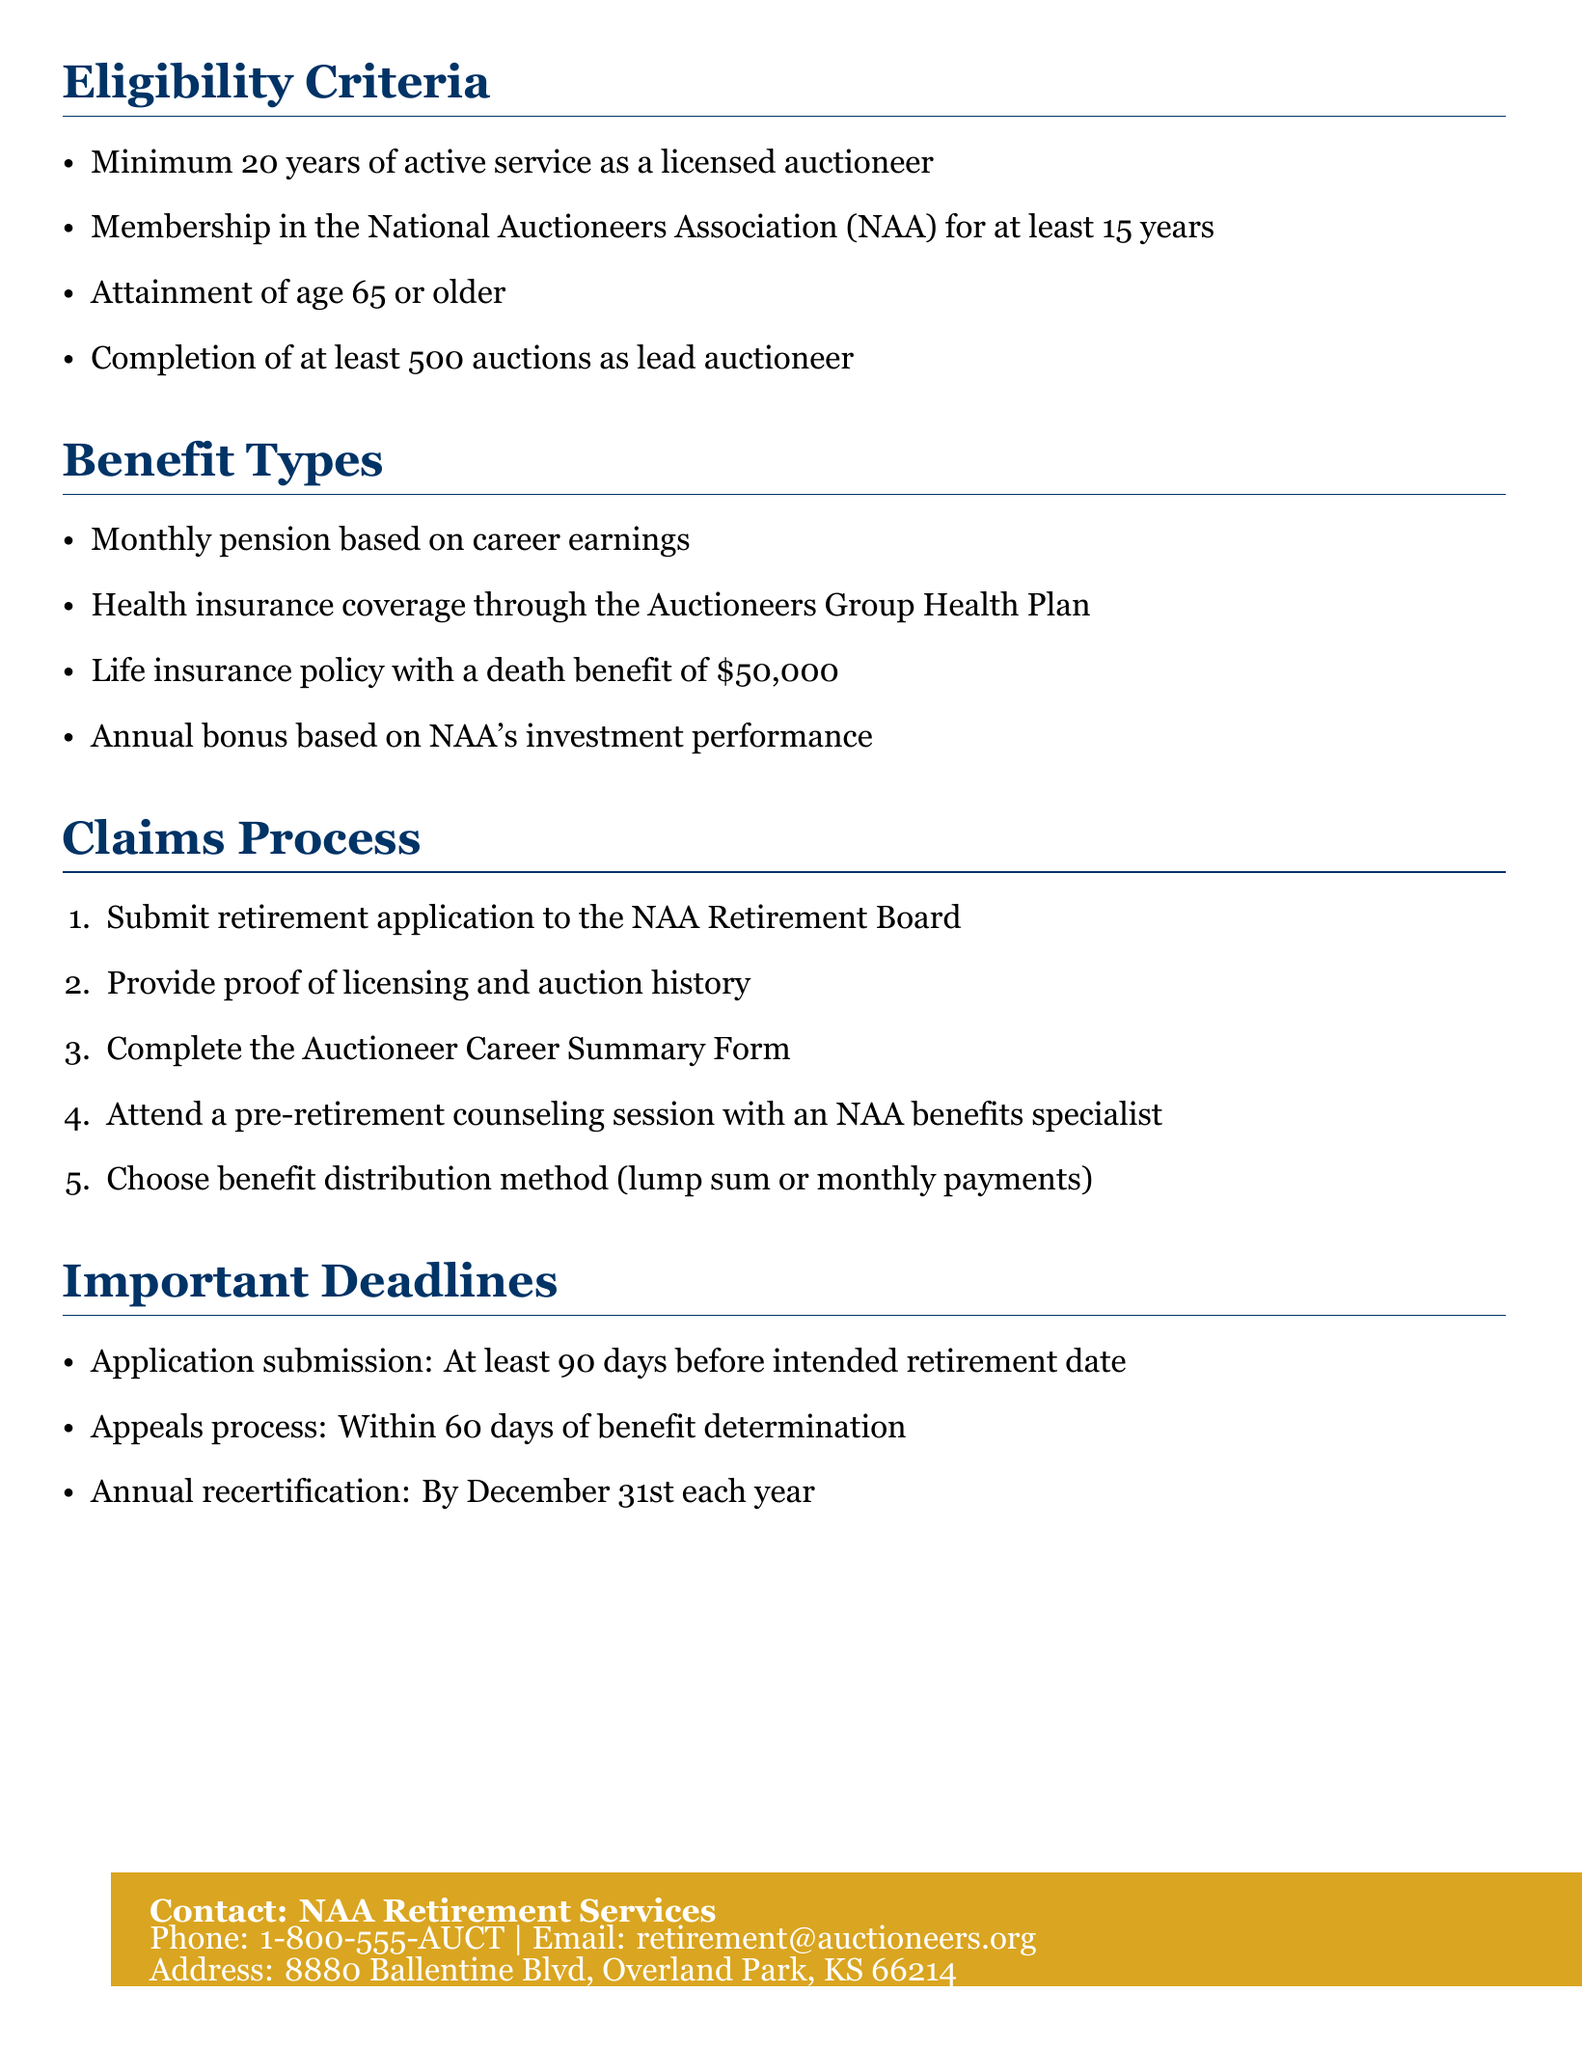what is the minimum years of active service required? The document states that a minimum of 20 years of active service as a licensed auctioneer is required for eligibility.
Answer: 20 years how many auctions must one have completed as lead auctioneer? According to the eligibility criteria, one must complete at least 500 auctions as a lead auctioneer.
Answer: 500 auctions what is the death benefit of the life insurance policy? The document specifies that the life insurance policy has a death benefit of $50,000.
Answer: $50,000 how many days before the intended retirement date must the application be submitted? It is stated in the document that the application submission must be at least 90 days before the intended retirement date.
Answer: 90 days who should retirement applications be submitted to? The document indicates that retirement applications should be submitted to the NAA Retirement Board.
Answer: NAA Retirement Board what is the age requirement for eligibility? The document notes that applicants must attain the age of 65 or older to be eligible.
Answer: 65 or older within how many days can one appeal a benefit determination? The document states that the appeals process must be initiated within 60 days of the benefit determination.
Answer: 60 days what type of health coverage is provided? The benefits include health insurance coverage through the Auctioneers Group Health Plan.
Answer: Auctioneers Group Health Plan what is the contact email for NAA Retirement Services? The document provides the contact email as retirement@auctioneers.org.
Answer: retirement@auctioneers.org 